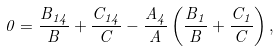<formula> <loc_0><loc_0><loc_500><loc_500>0 = \frac { B _ { 1 4 } } { B } + \frac { C _ { 1 4 } } { C } - \frac { A _ { 4 } } { A } \left ( \frac { B _ { 1 } } { B } + \frac { C _ { 1 } } { C } \right ) ,</formula> 